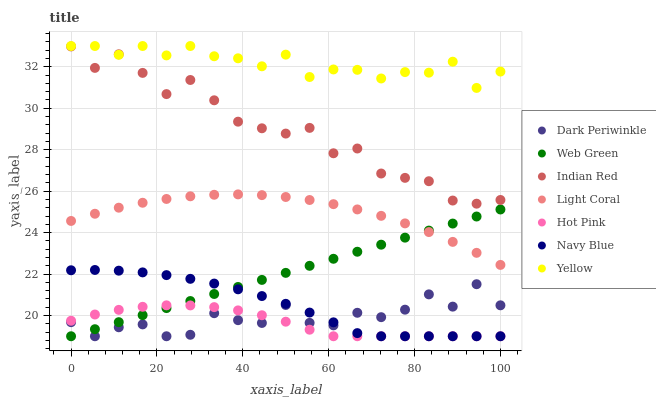Does Hot Pink have the minimum area under the curve?
Answer yes or no. Yes. Does Yellow have the maximum area under the curve?
Answer yes or no. Yes. Does Web Green have the minimum area under the curve?
Answer yes or no. No. Does Web Green have the maximum area under the curve?
Answer yes or no. No. Is Web Green the smoothest?
Answer yes or no. Yes. Is Dark Periwinkle the roughest?
Answer yes or no. Yes. Is Hot Pink the smoothest?
Answer yes or no. No. Is Hot Pink the roughest?
Answer yes or no. No. Does Navy Blue have the lowest value?
Answer yes or no. Yes. Does Light Coral have the lowest value?
Answer yes or no. No. Does Yellow have the highest value?
Answer yes or no. Yes. Does Web Green have the highest value?
Answer yes or no. No. Is Dark Periwinkle less than Yellow?
Answer yes or no. Yes. Is Yellow greater than Hot Pink?
Answer yes or no. Yes. Does Web Green intersect Hot Pink?
Answer yes or no. Yes. Is Web Green less than Hot Pink?
Answer yes or no. No. Is Web Green greater than Hot Pink?
Answer yes or no. No. Does Dark Periwinkle intersect Yellow?
Answer yes or no. No. 